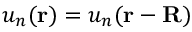Convert formula to latex. <formula><loc_0><loc_0><loc_500><loc_500>u _ { n } ( r ) = u _ { n } ( r - R )</formula> 